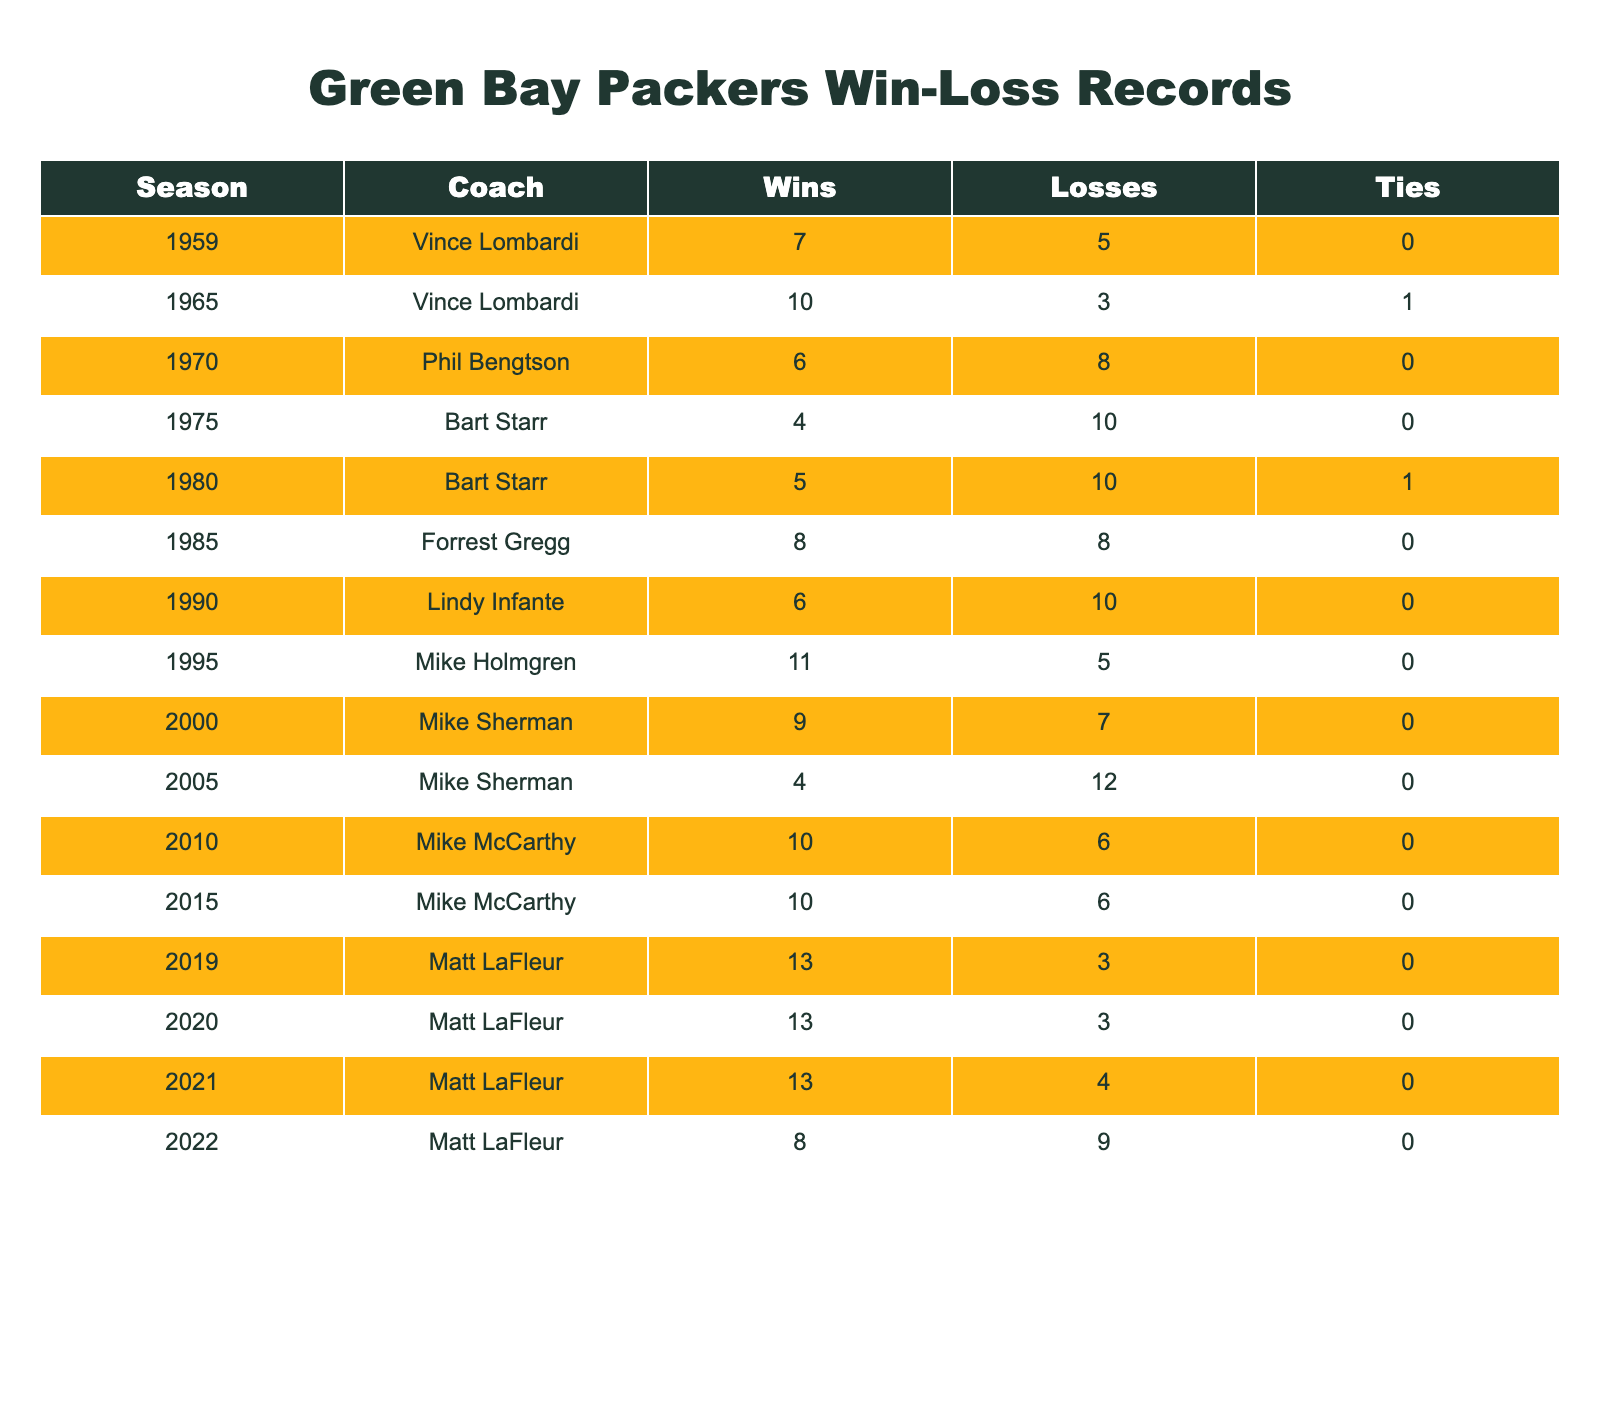What was the win-loss record for the Packers in the 1965 season? In the table, under the 1965 row, the Wins count is 10 and the Losses count is 3, so the record is 10 wins and 3 losses.
Answer: 10 wins, 3 losses Who was the head coach with the most wins in a single season? Observing the table, the highest Wins value is 13, attributed to Matt LaFleur in the 2019, 2020, and 2021 seasons.
Answer: Matt LaFleur What is the total number of wins the Packers achieved under Vince Lombardi? The table shows the Wins for Vince Lombardi in the 1959 (7) and 1965 (10) seasons. By adding these, 7 + 10 equals 17 total wins.
Answer: 17 Did the Packers have a losing record (more losses than wins) in the 1970 season? In the 1970 row, Wins are 6 and Losses are 8. Since there are more losses than wins, it indicates a losing record.
Answer: Yes Which coach had the lowest win total in a single season? Looking at the table, Bart Starr's 1975 season shows 4 wins and 10 losses. This is the lowest Wins value compared to all other coaches and seasons.
Answer: Bart Starr Calculate the average number of wins for the Packers during Matt LaFleur's tenure. Under Matt LaFleur (2019 to 2022), the Wins are 13 (2019), 13 (2020), 13 (2021), and 8 (2022). The total is 13 + 13 + 13 + 8 = 47. Dividing by 4 gives an average of 11.75.
Answer: 11.75 How many seasons did the Packers finish with a record of .500 (equal wins and losses)? The only entry with an equal number of Wins and Losses is the 1985 season (8 wins and 8 losses). Therefore, there is one such season.
Answer: 1 Was there a season where the Packers finished without any ties? The table shows that all entries have either 0 ties or specify a tie value in years with ties. Every season except 1965 (1 tie) has 0 ties.
Answer: Yes, except 1965 What was the overall trend in wins for the Packers from the 2010 season through 2022? In 2010, there were 10 wins; in 2015, there were also 10; in 2019 and 2020, there were 13 wins; but in 2022, it dropped to 8. The trend shows overall increasing wins until 2022.
Answer: Increasing then decreasing Identify the coach with the most seasons coached for the Packers. From the table, Mike McCarthy coached the Packers for 13 seasons (2010, 2015), while others coached for fewer.
Answer: Mike McCarthy 